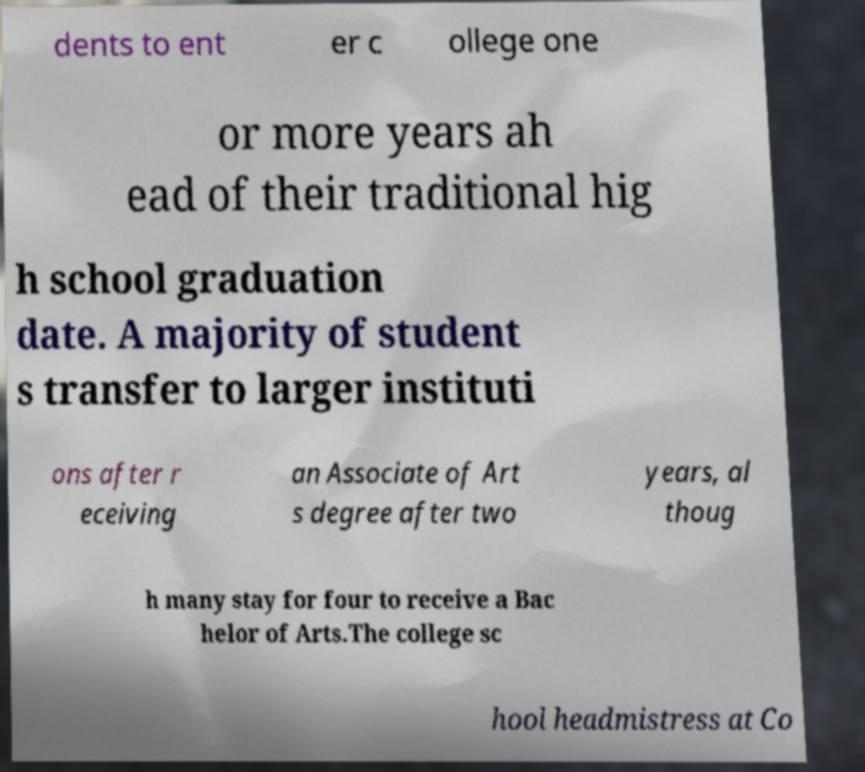What messages or text are displayed in this image? I need them in a readable, typed format. dents to ent er c ollege one or more years ah ead of their traditional hig h school graduation date. A majority of student s transfer to larger instituti ons after r eceiving an Associate of Art s degree after two years, al thoug h many stay for four to receive a Bac helor of Arts.The college sc hool headmistress at Co 